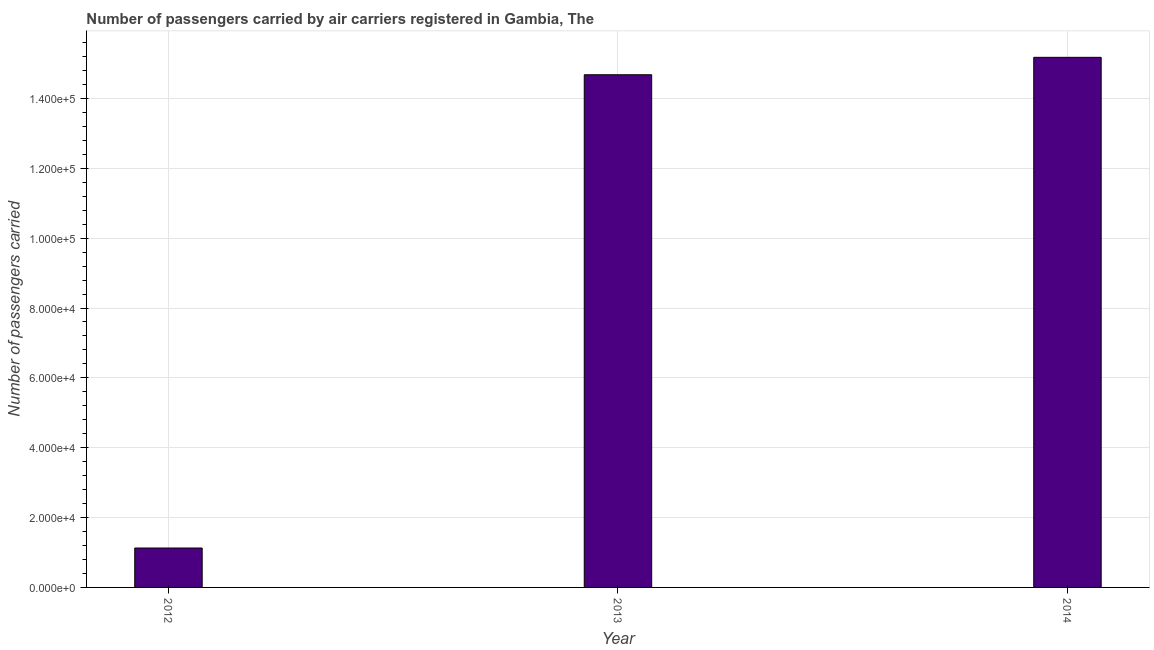Does the graph contain grids?
Provide a short and direct response. Yes. What is the title of the graph?
Give a very brief answer. Number of passengers carried by air carriers registered in Gambia, The. What is the label or title of the Y-axis?
Offer a terse response. Number of passengers carried. What is the number of passengers carried in 2012?
Keep it short and to the point. 1.13e+04. Across all years, what is the maximum number of passengers carried?
Your answer should be compact. 1.52e+05. Across all years, what is the minimum number of passengers carried?
Give a very brief answer. 1.13e+04. What is the sum of the number of passengers carried?
Give a very brief answer. 3.10e+05. What is the difference between the number of passengers carried in 2012 and 2014?
Ensure brevity in your answer.  -1.40e+05. What is the average number of passengers carried per year?
Your answer should be very brief. 1.03e+05. What is the median number of passengers carried?
Make the answer very short. 1.47e+05. In how many years, is the number of passengers carried greater than 112000 ?
Your response must be concise. 2. Do a majority of the years between 2014 and 2012 (inclusive) have number of passengers carried greater than 116000 ?
Your answer should be compact. Yes. What is the ratio of the number of passengers carried in 2012 to that in 2014?
Provide a succinct answer. 0.07. Is the difference between the number of passengers carried in 2012 and 2014 greater than the difference between any two years?
Give a very brief answer. Yes. What is the difference between the highest and the second highest number of passengers carried?
Keep it short and to the point. 4990.76. What is the difference between the highest and the lowest number of passengers carried?
Offer a very short reply. 1.40e+05. How many bars are there?
Offer a terse response. 3. What is the difference between two consecutive major ticks on the Y-axis?
Keep it short and to the point. 2.00e+04. What is the Number of passengers carried of 2012?
Give a very brief answer. 1.13e+04. What is the Number of passengers carried in 2013?
Offer a very short reply. 1.47e+05. What is the Number of passengers carried in 2014?
Ensure brevity in your answer.  1.52e+05. What is the difference between the Number of passengers carried in 2012 and 2013?
Your answer should be very brief. -1.36e+05. What is the difference between the Number of passengers carried in 2012 and 2014?
Make the answer very short. -1.40e+05. What is the difference between the Number of passengers carried in 2013 and 2014?
Ensure brevity in your answer.  -4990.75. What is the ratio of the Number of passengers carried in 2012 to that in 2013?
Provide a succinct answer. 0.08. What is the ratio of the Number of passengers carried in 2012 to that in 2014?
Give a very brief answer. 0.07. What is the ratio of the Number of passengers carried in 2013 to that in 2014?
Your answer should be very brief. 0.97. 